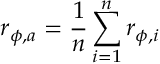Convert formula to latex. <formula><loc_0><loc_0><loc_500><loc_500>{ r _ { \phi , a } } = \frac { 1 } { n } \sum _ { i = 1 } ^ { n } { { r _ { \phi , i } } }</formula> 